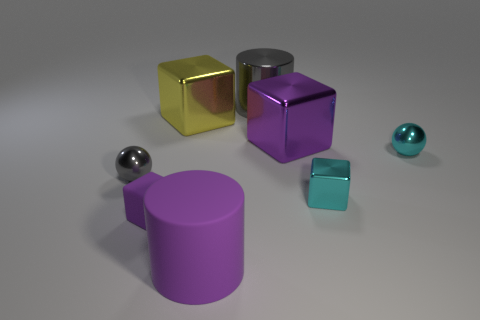Add 2 large cyan metallic cylinders. How many objects exist? 10 Subtract all cylinders. How many objects are left? 6 Add 7 large purple matte objects. How many large purple matte objects exist? 8 Subtract 1 gray cylinders. How many objects are left? 7 Subtract all small rubber blocks. Subtract all shiny cubes. How many objects are left? 4 Add 5 tiny cyan metallic objects. How many tiny cyan metallic objects are left? 7 